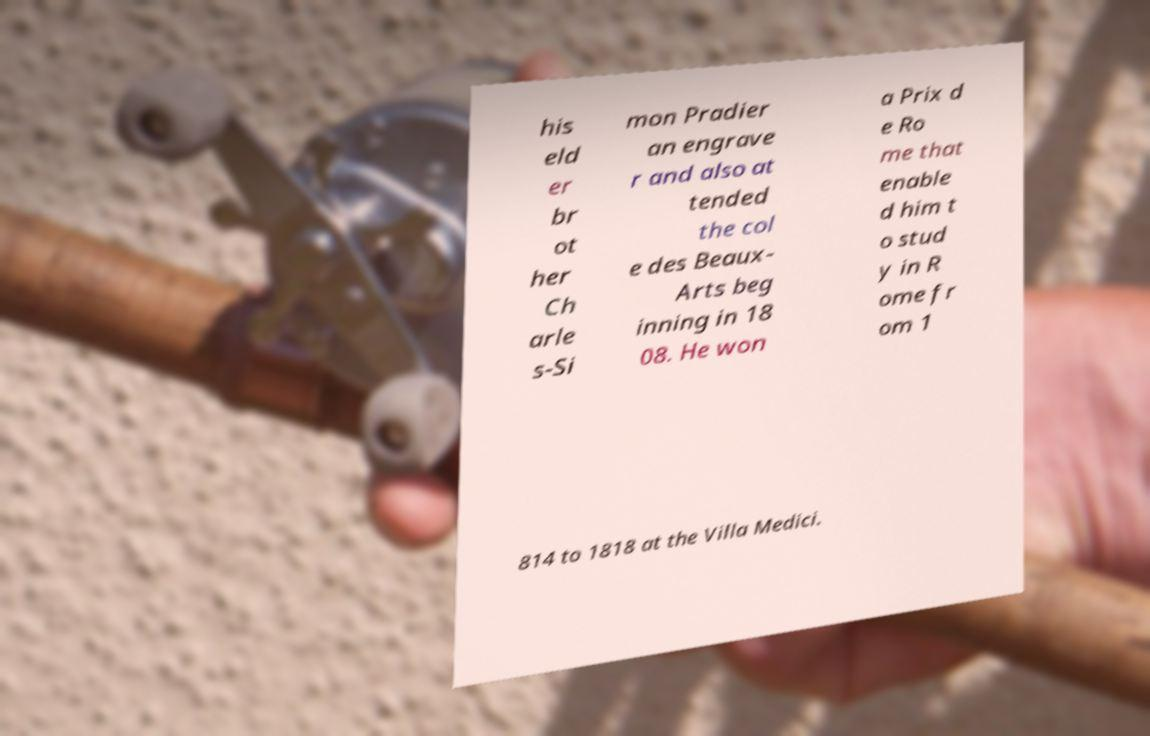Could you extract and type out the text from this image? his eld er br ot her Ch arle s-Si mon Pradier an engrave r and also at tended the col e des Beaux- Arts beg inning in 18 08. He won a Prix d e Ro me that enable d him t o stud y in R ome fr om 1 814 to 1818 at the Villa Medici. 